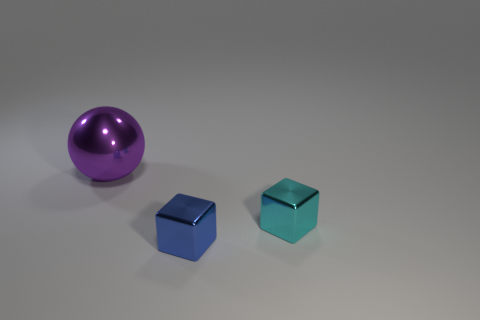What might be the mood or atmosphere implied by this setting? The image creates a minimalistic and serene atmosphere. The clean lines, the sparsity of objects, and the neutral background all contribute to a peaceful, uncluttered mood. There is an element of modernity in the simplicity of the composition, which some might interpret as a tranquil or contemplative scene, often found in modern art galleries or in designs emphasizing negative space and simplicity. 